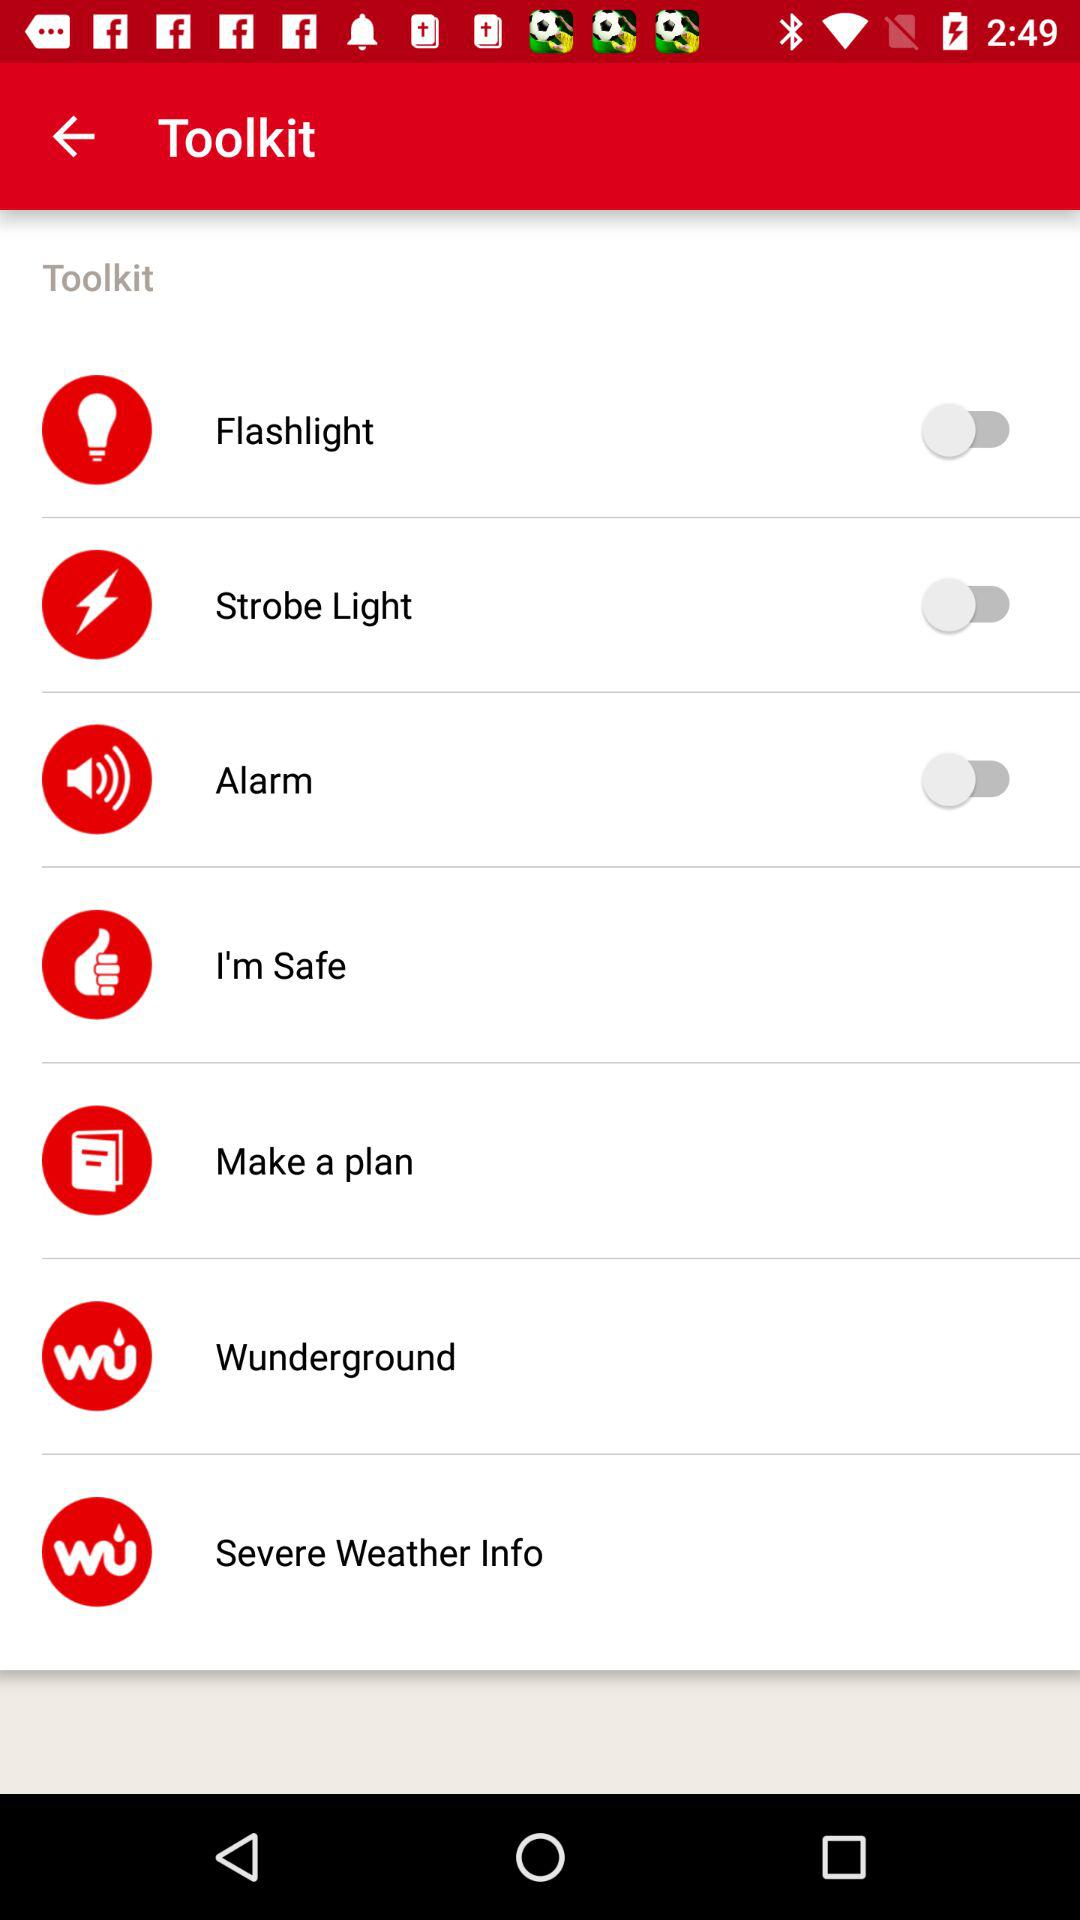Is the "Flashlight" on or off? The "Flashlight" is off. 